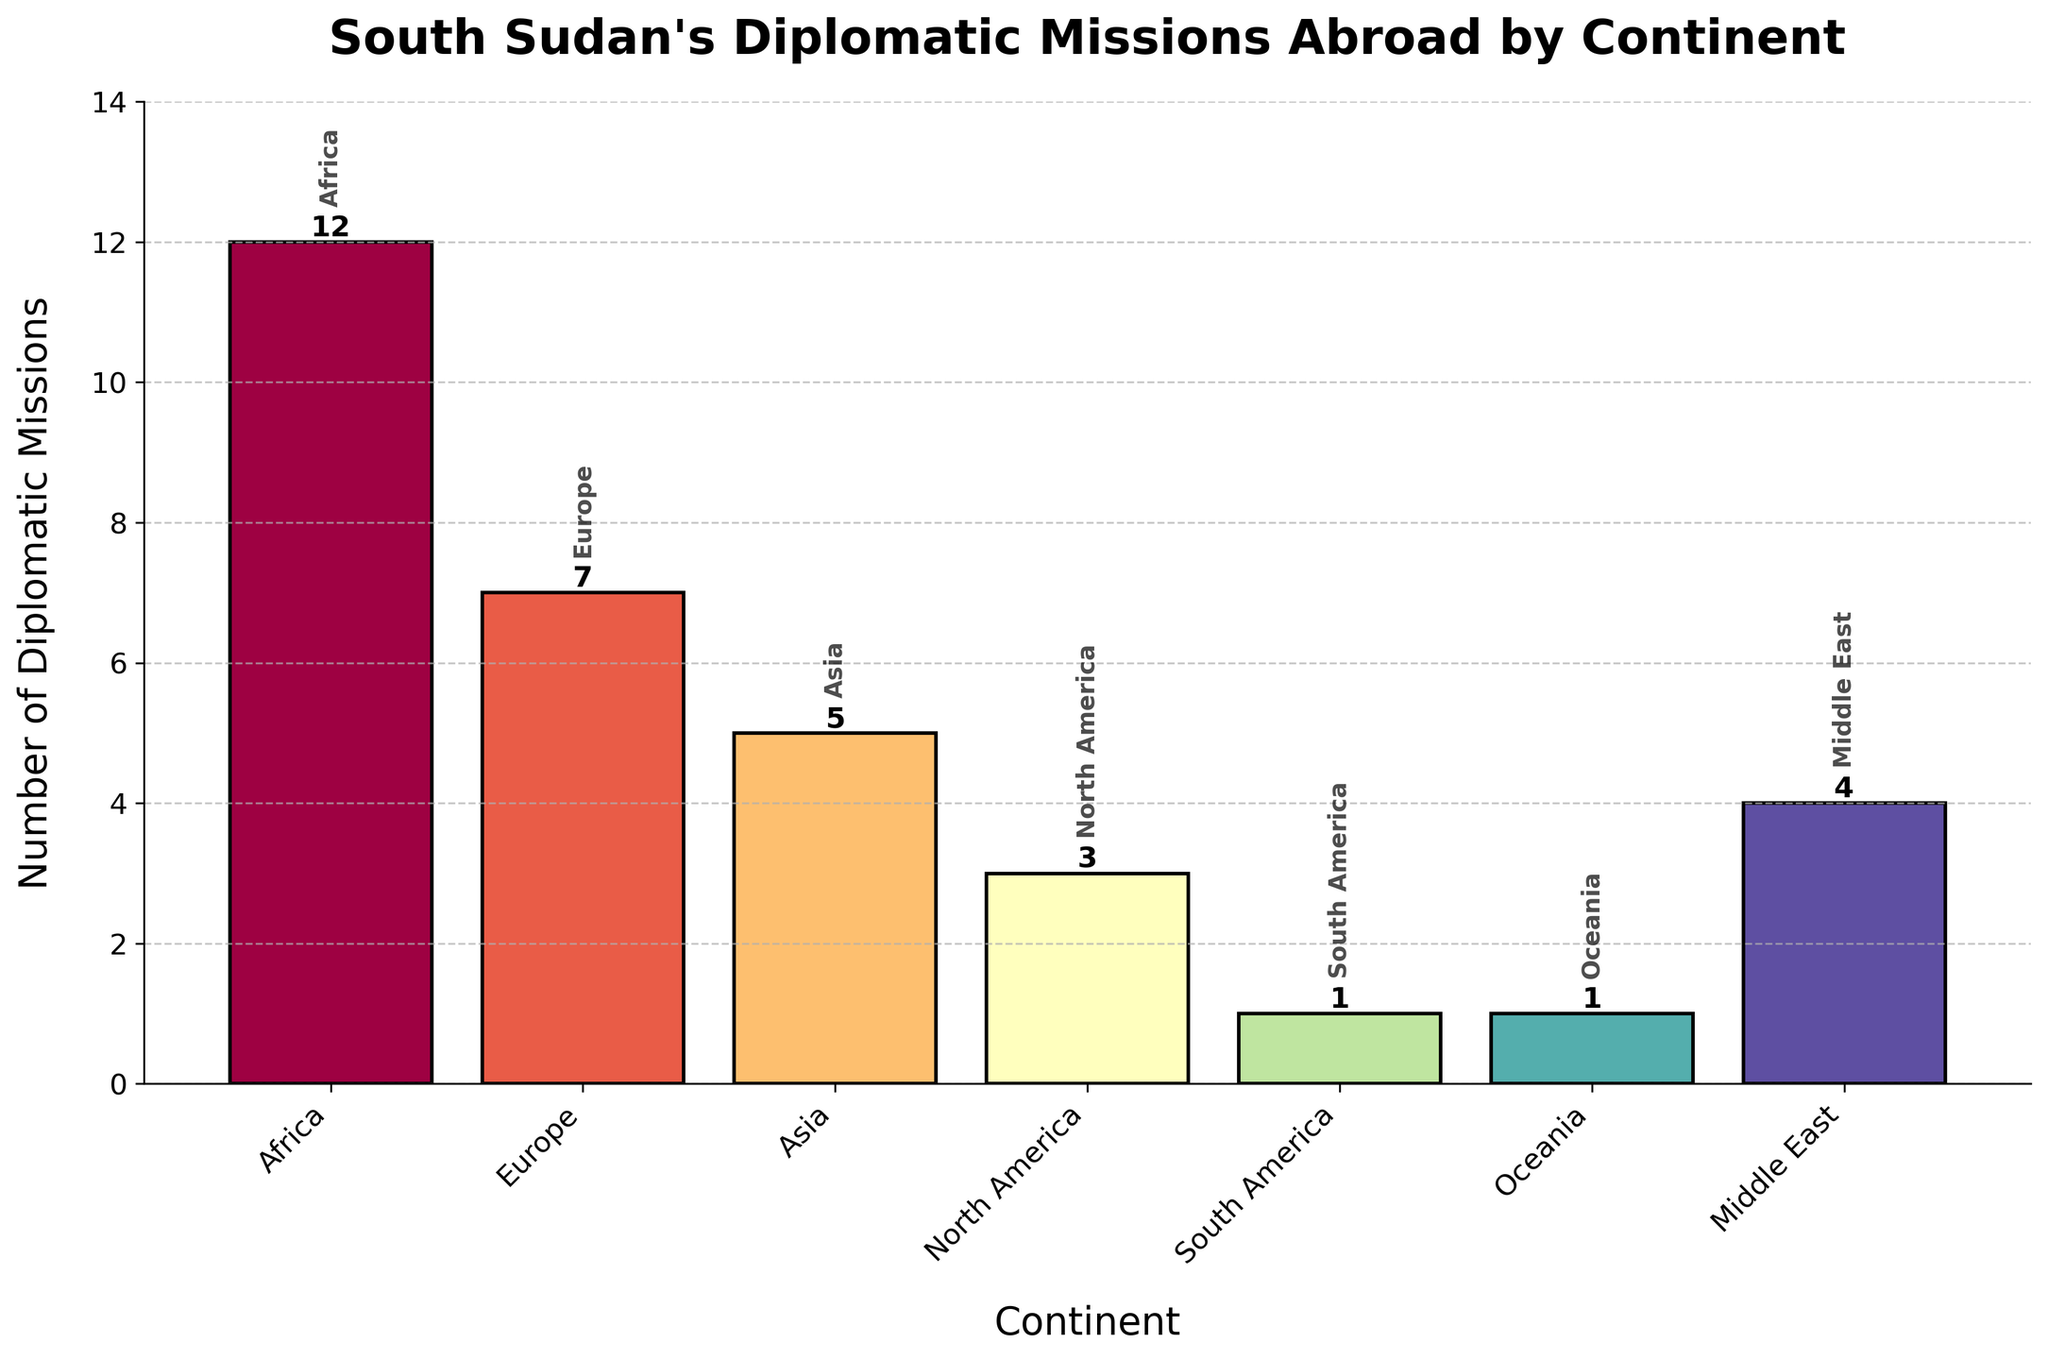What continent hosts the highest number of South Sudan's diplomatic missions? By observing the heights of the bars in the bar chart, the continent with the tallest bar represents the highest number of diplomatic missions. The tallest bar corresponds to Africa.
Answer: Africa What is the total number of diplomatic missions in Europe and Asia combined? Sum the number of diplomatic missions for Europe and Asia. Europe has 7 and Asia has 5. So, 7 + 5 = 12.
Answer: 12 Which continent has fewer diplomatic missions: North America or Middle East? Compare the heights of the bars representing North America and Middle East. North America has 3 diplomatic missions, while Middle East has 4. Since 3 is less than 4, North America has fewer diplomatic missions.
Answer: North America Calculate the difference in the number of diplomatic missions between Africa and Oceania. Subtract the number of diplomatic missions in Oceania from the number in Africa. Africa has 12 and Oceania has 1. So, 12 - 1 = 11.
Answer: 11 What is the average number of diplomatic missions across all continents? Add the number of diplomatic missions for all continents (12 + 7 + 5 + 3 + 1 + 1 + 4) and divide by the number of continents (7). Thus, (12 + 7 + 5 + 3 + 1 + 1 + 4) / 7 = 33 / 7 ≈ 4.71.
Answer: 4.71 Which continents have the same number of diplomatic missions? Compare the heights of the bars. South America and Oceania both have 1 diplomatic mission each.
Answer: South America and Oceania What is the sum of the number of diplomatic missions in Africa, Middle East, and Europe? Add the number of diplomatic missions in these continents. Africa has 12, Middle East has 4, and Europe has 7. So, 12 + 4 + 7 = 23.
Answer: 23 If South Sudan opens 2 more diplomatic missions in Asia, which continent will have more diplomatic missions: Asia or Europe? First, add 2 more missions to Asia's total. Asia would then have 5 + 2 = 7. Since Europe also has 7, Asia and Europe would have an equal number of diplomatic missions.
Answer: Equal 